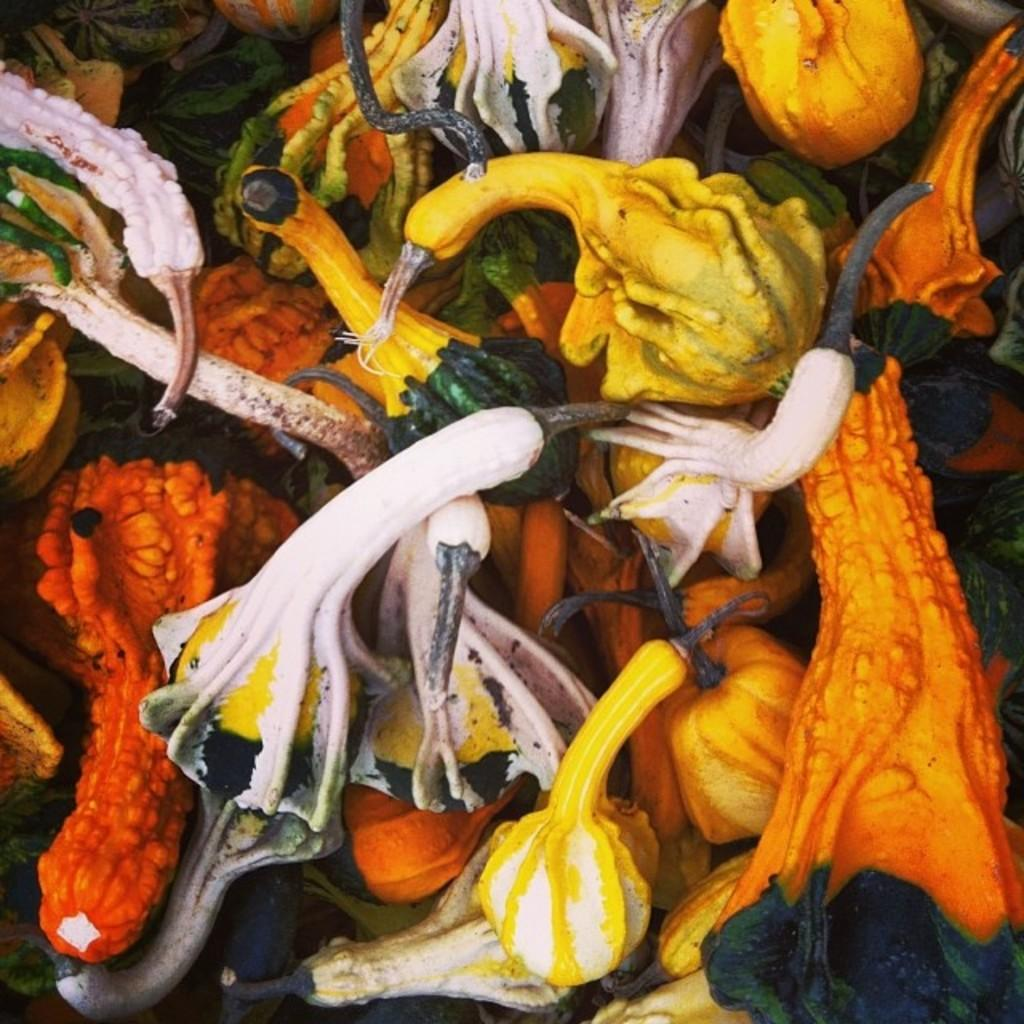What type of plants can be seen in the image? There are flowers in the image. Can you describe the appearance of the flowers? The flowers have different colors. What type of tool is used to maintain the flowers in the image? There is no tool visible in the image, and therefore it cannot be determined what might be used to maintain the flowers. 